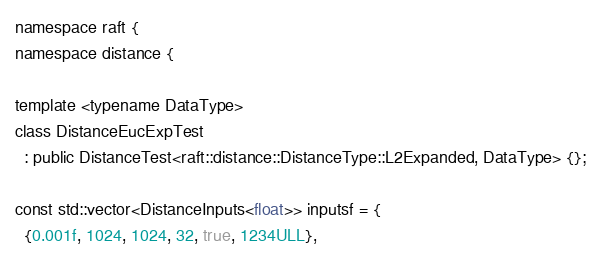Convert code to text. <code><loc_0><loc_0><loc_500><loc_500><_Cuda_>namespace raft {
namespace distance {

template <typename DataType>
class DistanceEucExpTest
  : public DistanceTest<raft::distance::DistanceType::L2Expanded, DataType> {};

const std::vector<DistanceInputs<float>> inputsf = {
  {0.001f, 1024, 1024, 32, true, 1234ULL},</code> 